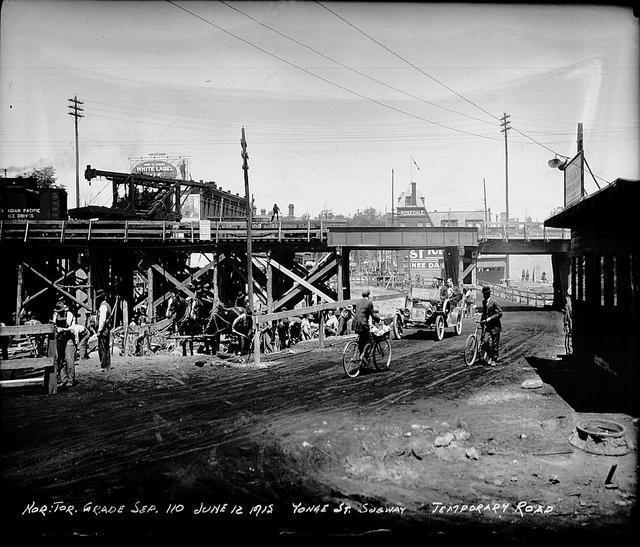How many giraffes are looking to the left?
Give a very brief answer. 0. 